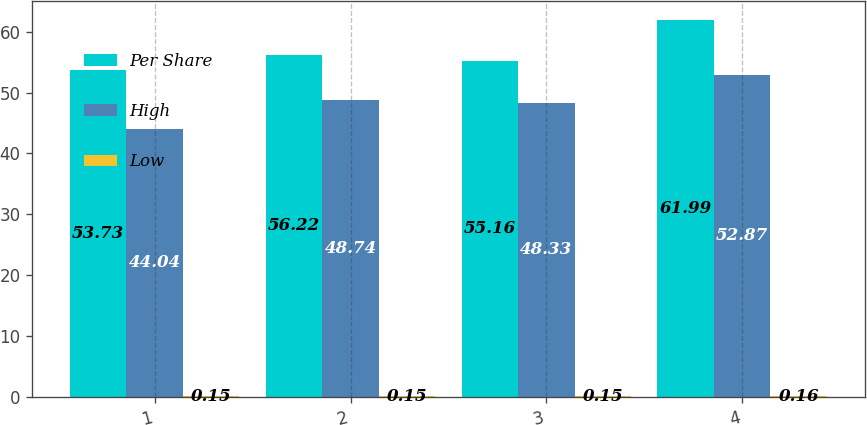<chart> <loc_0><loc_0><loc_500><loc_500><stacked_bar_chart><ecel><fcel>1<fcel>2<fcel>3<fcel>4<nl><fcel>Per Share<fcel>53.73<fcel>56.22<fcel>55.16<fcel>61.99<nl><fcel>High<fcel>44.04<fcel>48.74<fcel>48.33<fcel>52.87<nl><fcel>Low<fcel>0.15<fcel>0.15<fcel>0.15<fcel>0.16<nl></chart> 